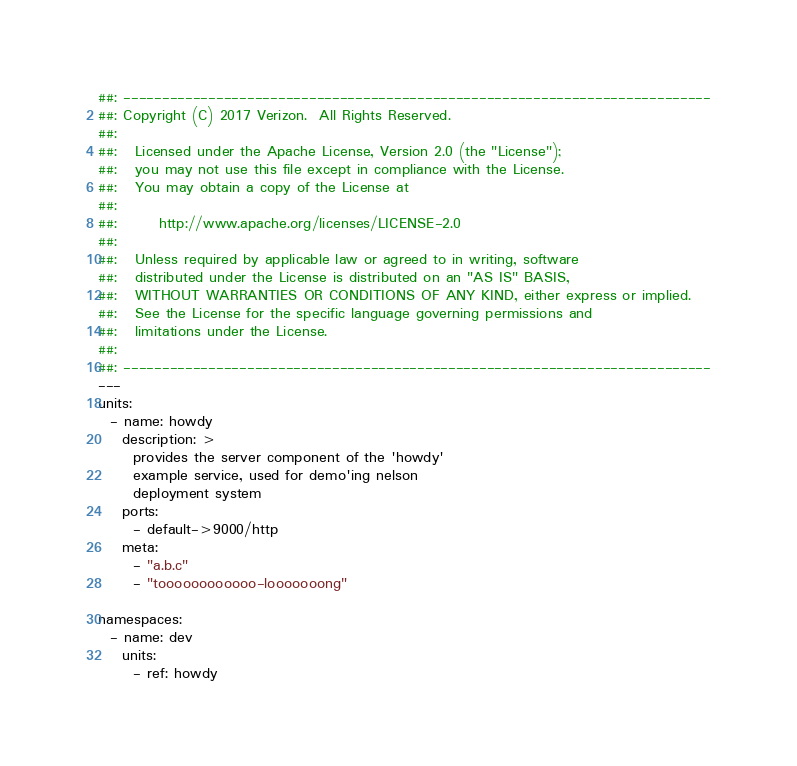<code> <loc_0><loc_0><loc_500><loc_500><_YAML_>##: ----------------------------------------------------------------------------
##: Copyright (C) 2017 Verizon.  All Rights Reserved.
##:
##:   Licensed under the Apache License, Version 2.0 (the "License");
##:   you may not use this file except in compliance with the License.
##:   You may obtain a copy of the License at
##:
##:       http://www.apache.org/licenses/LICENSE-2.0
##:
##:   Unless required by applicable law or agreed to in writing, software
##:   distributed under the License is distributed on an "AS IS" BASIS,
##:   WITHOUT WARRANTIES OR CONDITIONS OF ANY KIND, either express or implied.
##:   See the License for the specific language governing permissions and
##:   limitations under the License.
##:
##: ----------------------------------------------------------------------------
---
units:
  - name: howdy
    description: >
      provides the server component of the 'howdy'
      example service, used for demo'ing nelson
      deployment system
    ports:
      - default->9000/http
    meta:
      - "a.b.c"
      - "toooooooooooo-looooooong"  

namespaces:
  - name: dev
    units:
      - ref: howdy
</code> 